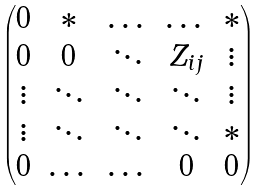<formula> <loc_0><loc_0><loc_500><loc_500>\begin{pmatrix} 0 & * & \dots & \dots & * \\ 0 & 0 & \ddots & Z _ { i j } & \vdots \\ \vdots & \ddots & \ddots & \ddots & \vdots \\ \vdots & \ddots & \ddots & \ddots & * \\ 0 & \dots & \dots & 0 & 0 \end{pmatrix}</formula> 